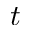<formula> <loc_0><loc_0><loc_500><loc_500>t</formula> 